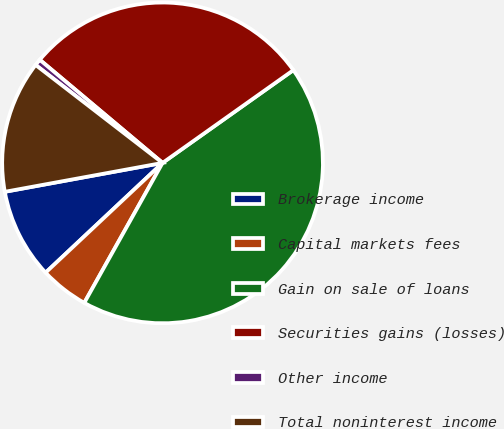Convert chart to OTSL. <chart><loc_0><loc_0><loc_500><loc_500><pie_chart><fcel>Brokerage income<fcel>Capital markets fees<fcel>Gain on sale of loans<fcel>Securities gains (losses)<fcel>Other income<fcel>Total noninterest income<nl><fcel>9.11%<fcel>4.89%<fcel>42.93%<fcel>29.06%<fcel>0.66%<fcel>13.34%<nl></chart> 